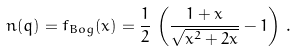<formula> <loc_0><loc_0><loc_500><loc_500>n ( q ) = f _ { B o g } ( x ) = \frac { 1 } { 2 } \, \left ( \frac { 1 + x } { \sqrt { x ^ { 2 } + 2 x } } - 1 \right ) \, .</formula> 